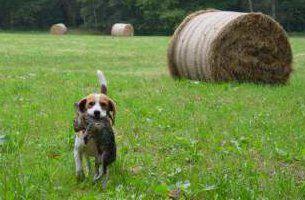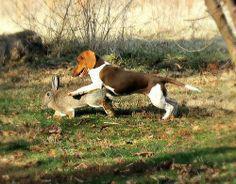The first image is the image on the left, the second image is the image on the right. Assess this claim about the two images: "There is a single person standing with a group of dogs in one of the images.". Correct or not? Answer yes or no. No. The first image is the image on the left, the second image is the image on the right. Analyze the images presented: Is the assertion "1 dog has a tail that is sticking up." valid? Answer yes or no. Yes. The first image is the image on the left, the second image is the image on the right. For the images displayed, is the sentence "At least one of the images shows only one dog." factually correct? Answer yes or no. Yes. The first image is the image on the left, the second image is the image on the right. Analyze the images presented: Is the assertion "At least one of the images contains one or more rabbits." valid? Answer yes or no. Yes. 